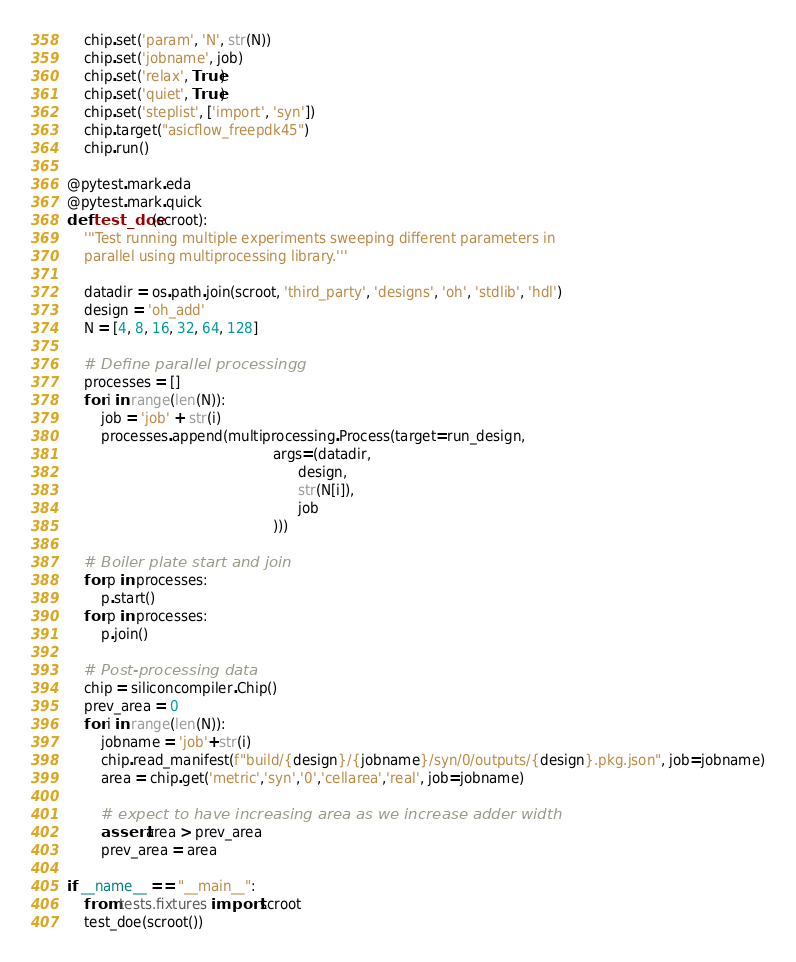<code> <loc_0><loc_0><loc_500><loc_500><_Python_>    chip.set('param', 'N', str(N))
    chip.set('jobname', job)
    chip.set('relax', True)
    chip.set('quiet', True)
    chip.set('steplist', ['import', 'syn'])
    chip.target("asicflow_freepdk45")
    chip.run()

@pytest.mark.eda
@pytest.mark.quick
def test_doe(scroot):
    '''Test running multiple experiments sweeping different parameters in
    parallel using multiprocessing library.'''

    datadir = os.path.join(scroot, 'third_party', 'designs', 'oh', 'stdlib', 'hdl')
    design = 'oh_add'
    N = [4, 8, 16, 32, 64, 128]

    # Define parallel processingg
    processes = []
    for i in range(len(N)):
        job = 'job' + str(i)
        processes.append(multiprocessing.Process(target=run_design,
                                                args=(datadir,
                                                      design,
                                                      str(N[i]),
                                                      job
                                                )))

    # Boiler plate start and join
    for p in processes:
        p.start()
    for p in processes:
        p.join()

    # Post-processing data
    chip = siliconcompiler.Chip()
    prev_area = 0
    for i in range(len(N)):
        jobname = 'job'+str(i)
        chip.read_manifest(f"build/{design}/{jobname}/syn/0/outputs/{design}.pkg.json", job=jobname)
        area = chip.get('metric','syn','0','cellarea','real', job=jobname)

        # expect to have increasing area as we increase adder width
        assert area > prev_area
        prev_area = area

if __name__ == "__main__":
    from tests.fixtures import scroot
    test_doe(scroot())
</code> 